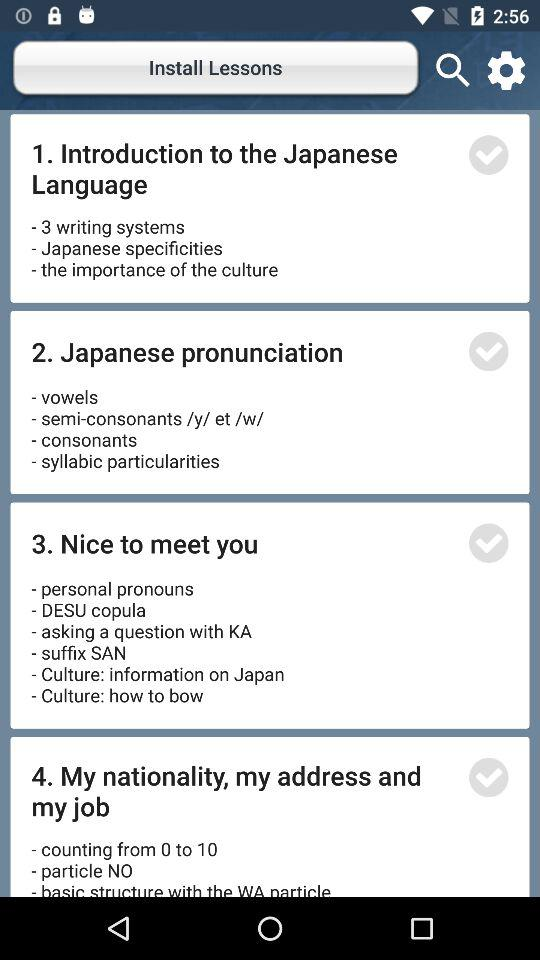What are the contents of the lesson on Japanese pronunciation? The contents are "vowels", "semi-consonants /y/ et /w/", "consonants" and "syllabic particularities". 